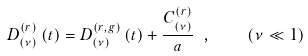<formula> <loc_0><loc_0><loc_500><loc_500>D _ { \left ( \nu \right ) } ^ { \left ( r \right ) } \left ( t \right ) = D _ { \left ( \nu \right ) } ^ { \left ( r , g \right ) } \left ( t \right ) + \frac { C _ { \left ( \nu \right ) } ^ { \left ( r \right ) } } { a } \ , \quad \left ( \nu \ll 1 \right )</formula> 